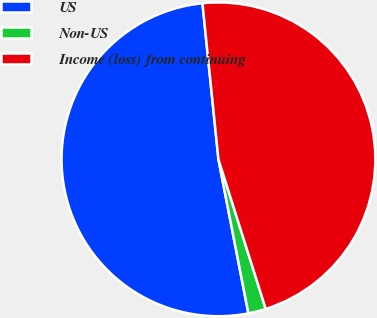Convert chart. <chart><loc_0><loc_0><loc_500><loc_500><pie_chart><fcel>US<fcel>Non-US<fcel>Income (loss) from continuing<nl><fcel>51.43%<fcel>1.82%<fcel>46.75%<nl></chart> 